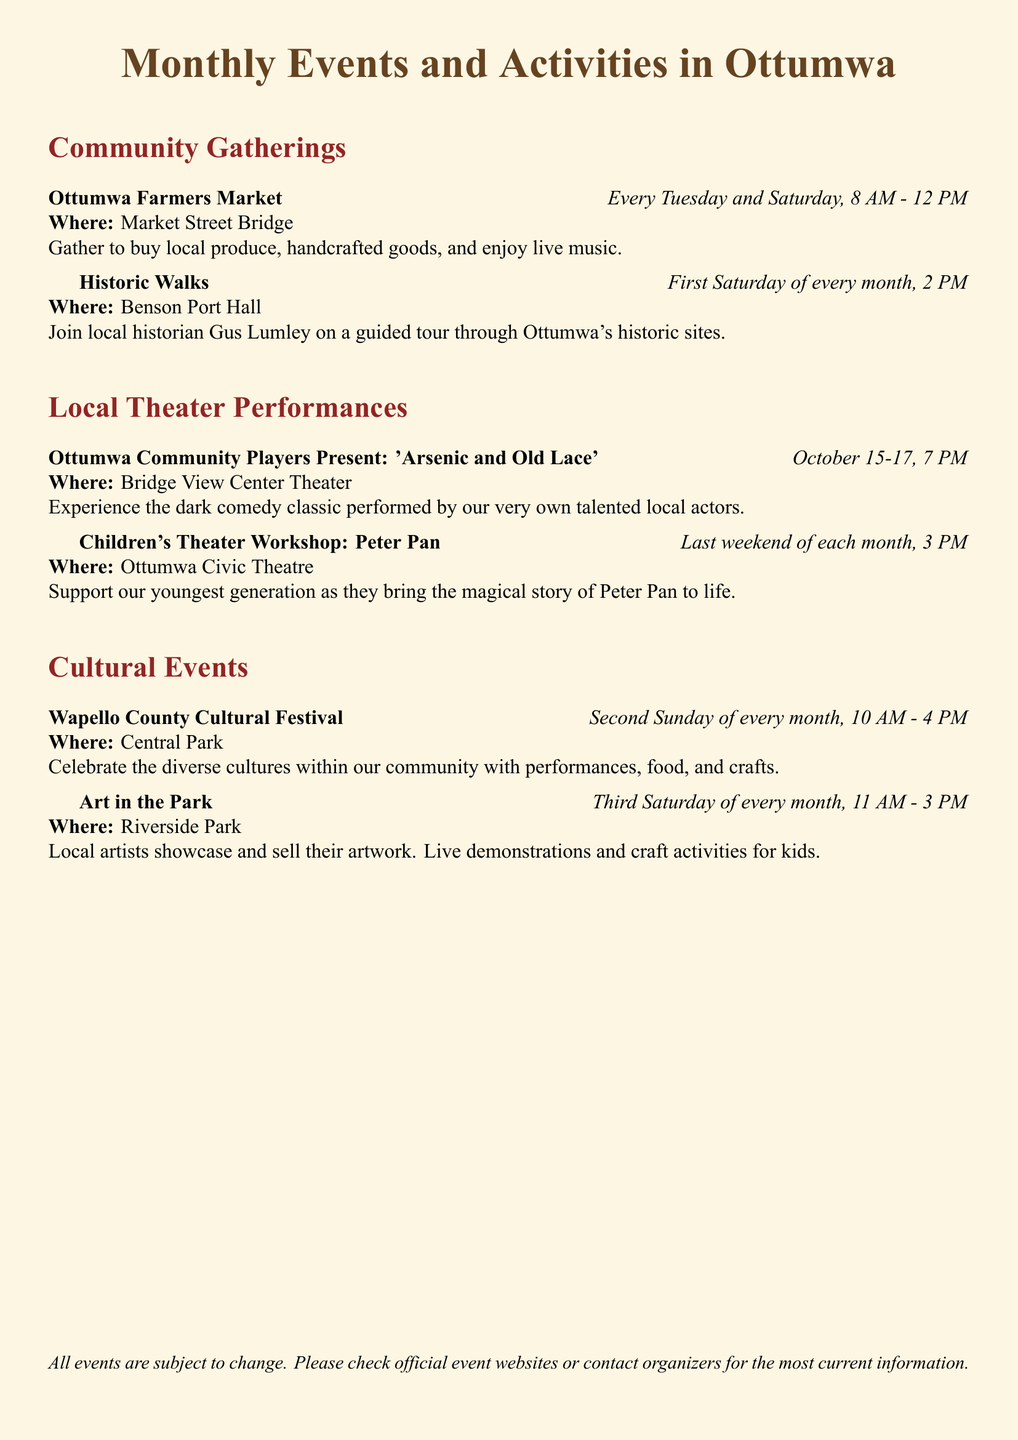What day is the Ottumwa Farmers Market held? The Ottumwa Farmers Market takes place every Tuesday and Saturday as listed in the document.
Answer: Tuesday and Saturday Who joins the Historic Walks? Local historian Gus Lumley leads the Historic Walks as mentioned in the document.
Answer: Gus Lumley When does the Children's Theater Workshop take place? The document states that the Children's Theater Workshop occurs on the last weekend of each month at 3 PM.
Answer: Last weekend of each month Where is the Wapello County Cultural Festival held? The location for the Wapello County Cultural Festival is Central Park, as indicated in the document.
Answer: Central Park What time does Art in the Park start? According to the document, Art in the Park starts at 11 AM.
Answer: 11 AM How often does the Cultural Festival occur? The document specifies that the Wapello County Cultural Festival happens every second Sunday of the month.
Answer: Every second Sunday What type of performances are included in the Ottumwa Community Players event? The document describes the performance as a dark comedy classic, referring to 'Arsenic and Old Lace.'
Answer: Dark comedy classic Which park hosts Art in the Park? Riverside Park is where Art in the Park is hosted, as mentioned in the document.
Answer: Riverside Park 